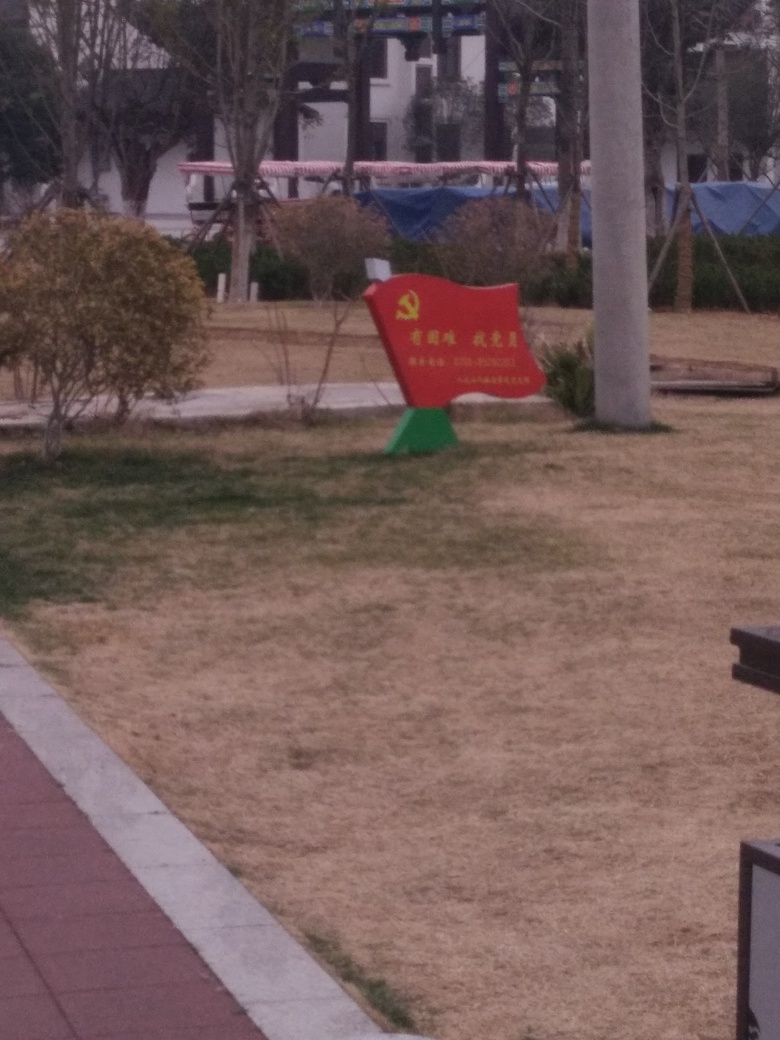What time of the year does this image most likely represent, and what clues from the environment suggest this? The image most likely represents a time in late autumn or winter, suggested by the dry and faded grass that usually occurs due to colder temperatures and less rainfall. The absence of leaves on the trees in the background also indicates a season where vegetation experiences dormancy. 